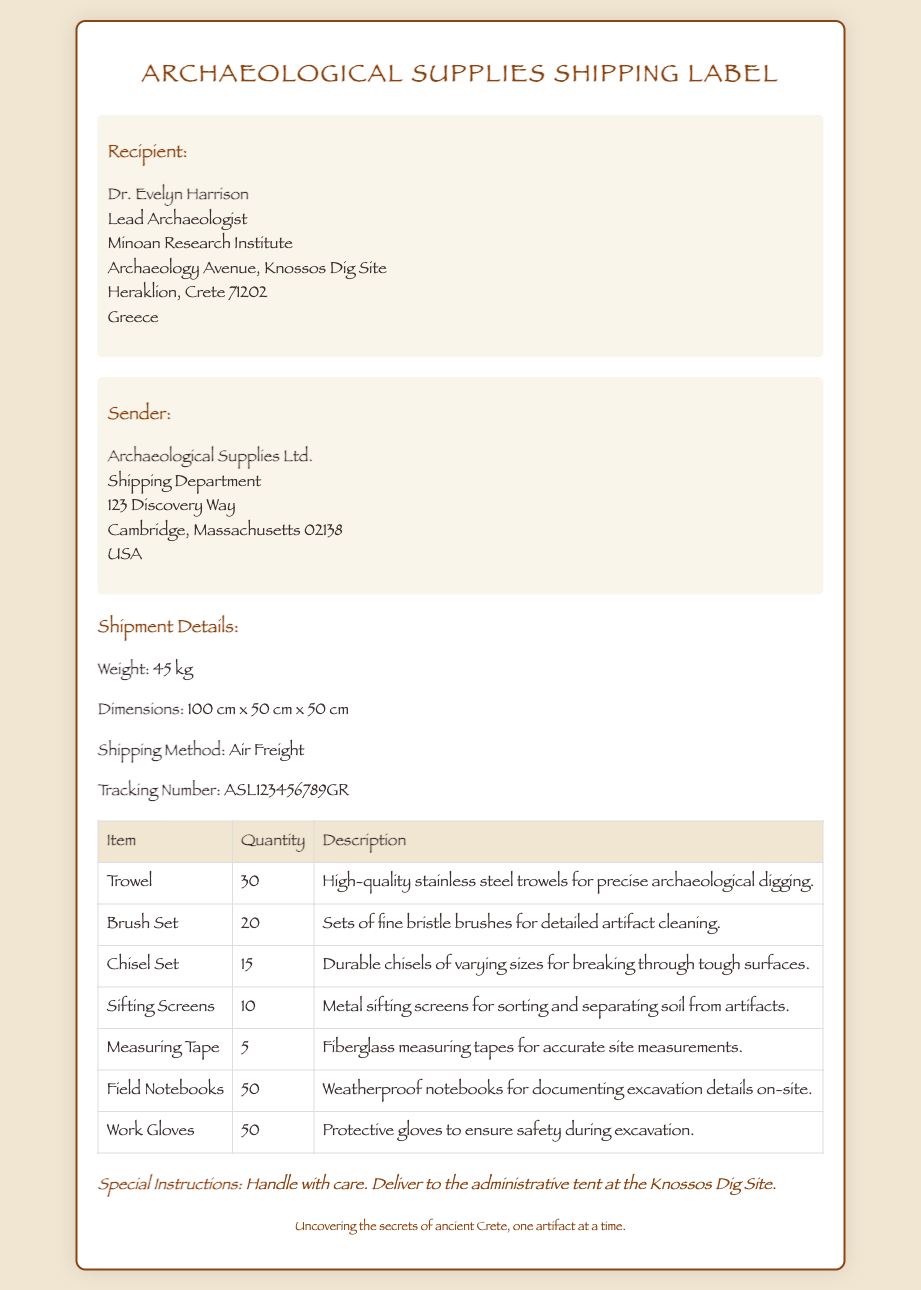What is the recipient's name? The name of the recipient is mentioned at the top of the address section as Dr. Evelyn Harrison.
Answer: Dr. Evelyn Harrison What is the shipping method used for this shipment? The shipping method is specified in the shipment details as Air Freight.
Answer: Air Freight How many trowels are included in the shipment? The quantity of trowels is detailed in the items table as 30.
Answer: 30 What is the weight of the shipment? The weight is provided in the shipment details section as 45 kg.
Answer: 45 kg What special instructions are given for the shipment? The special instructions specify that the shipment should be handled with care and delivered to the administrative tent.
Answer: Handle with care. Deliver to the administrative tent at the Knossos Dig Site How many items are there in total that are being shipped? The total number of different items is found by counting the rows in the items table, which totals 7 items.
Answer: 7 items What is the tracking number for this shipment? The tracking number can be found in the shipment details as ASL123456789GR.
Answer: ASL123456789GR What is the address of the sender? The sender's address includes the company name and location, which is Archaeological Supplies Ltd., 123 Discovery Way, Cambridge, Massachusetts 02138, USA.
Answer: Archaeological Supplies Ltd., 123 Discovery Way, Cambridge, Massachusetts 02138, USA What are the dimensions of the shipment? The dimensions of the shipment are provided in the shipment details as 100 cm x 50 cm x 50 cm.
Answer: 100 cm x 50 cm x 50 cm 